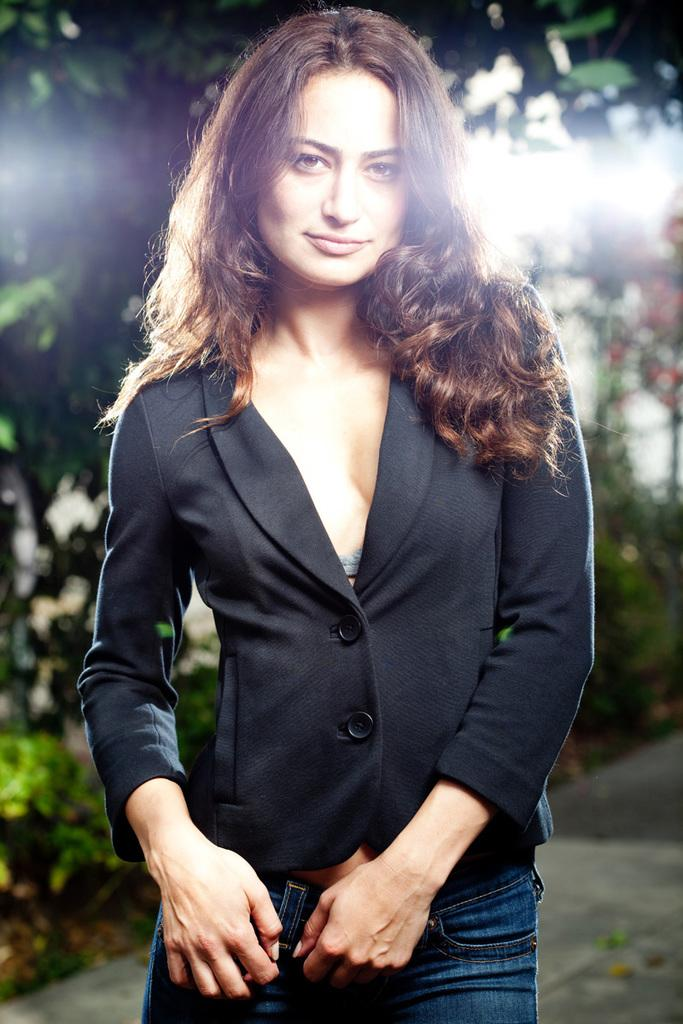Who is the main subject in the image? There is a woman in the image. What is the woman doing in the image? The woman is standing and smiling. Can you describe the background of the image? The background of the image is blurry, but leaves are visible. What type of quartz can be seen in the woman's hand in the image? There is no quartz present in the image; the woman is not holding anything. What is the woman's thought process while standing in the image? The image does not provide information about the woman's thought process, as it only shows her standing and smiling. 